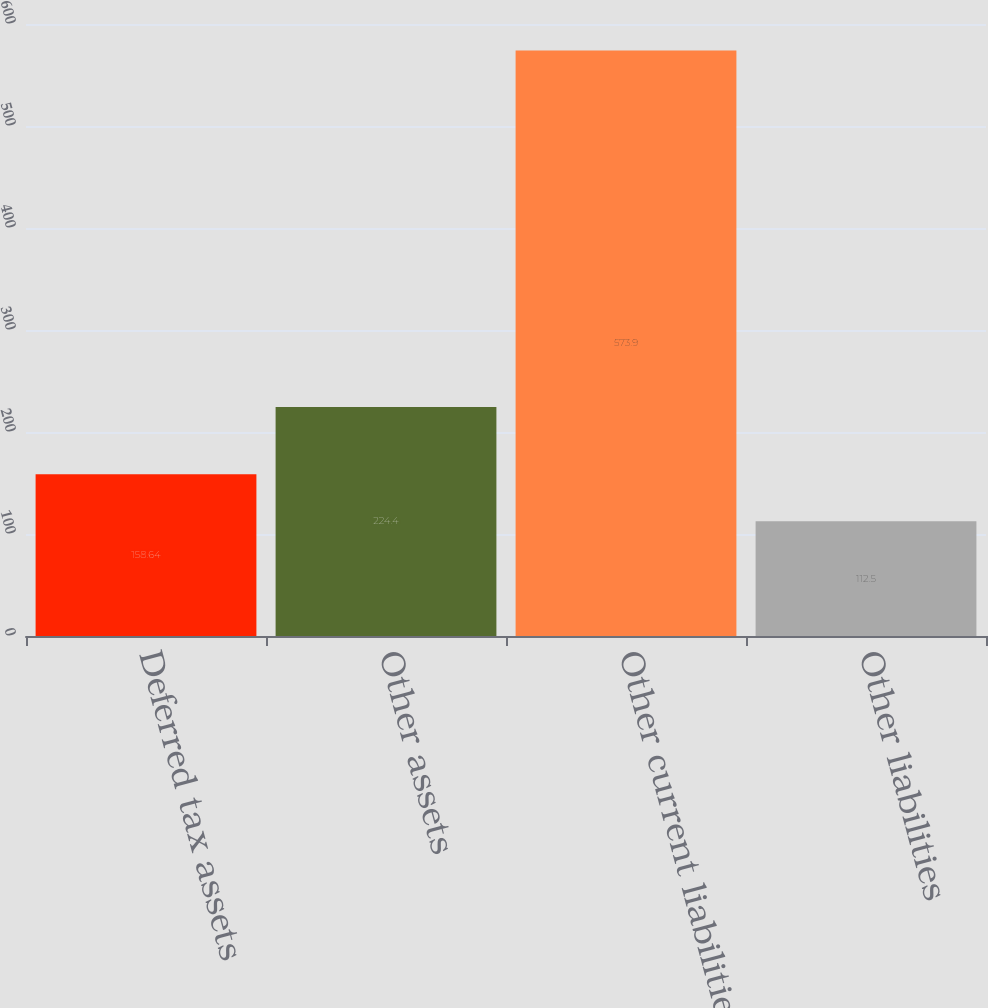<chart> <loc_0><loc_0><loc_500><loc_500><bar_chart><fcel>Deferred tax assets<fcel>Other assets<fcel>Other current liabilities<fcel>Other liabilities<nl><fcel>158.64<fcel>224.4<fcel>573.9<fcel>112.5<nl></chart> 